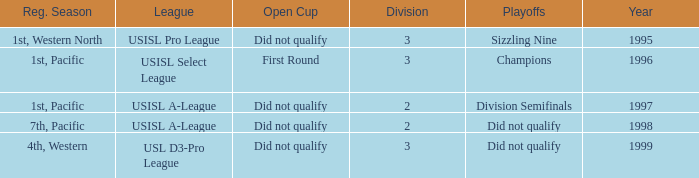How many years was there a team that was part of the usisl pro league? 1.0. 